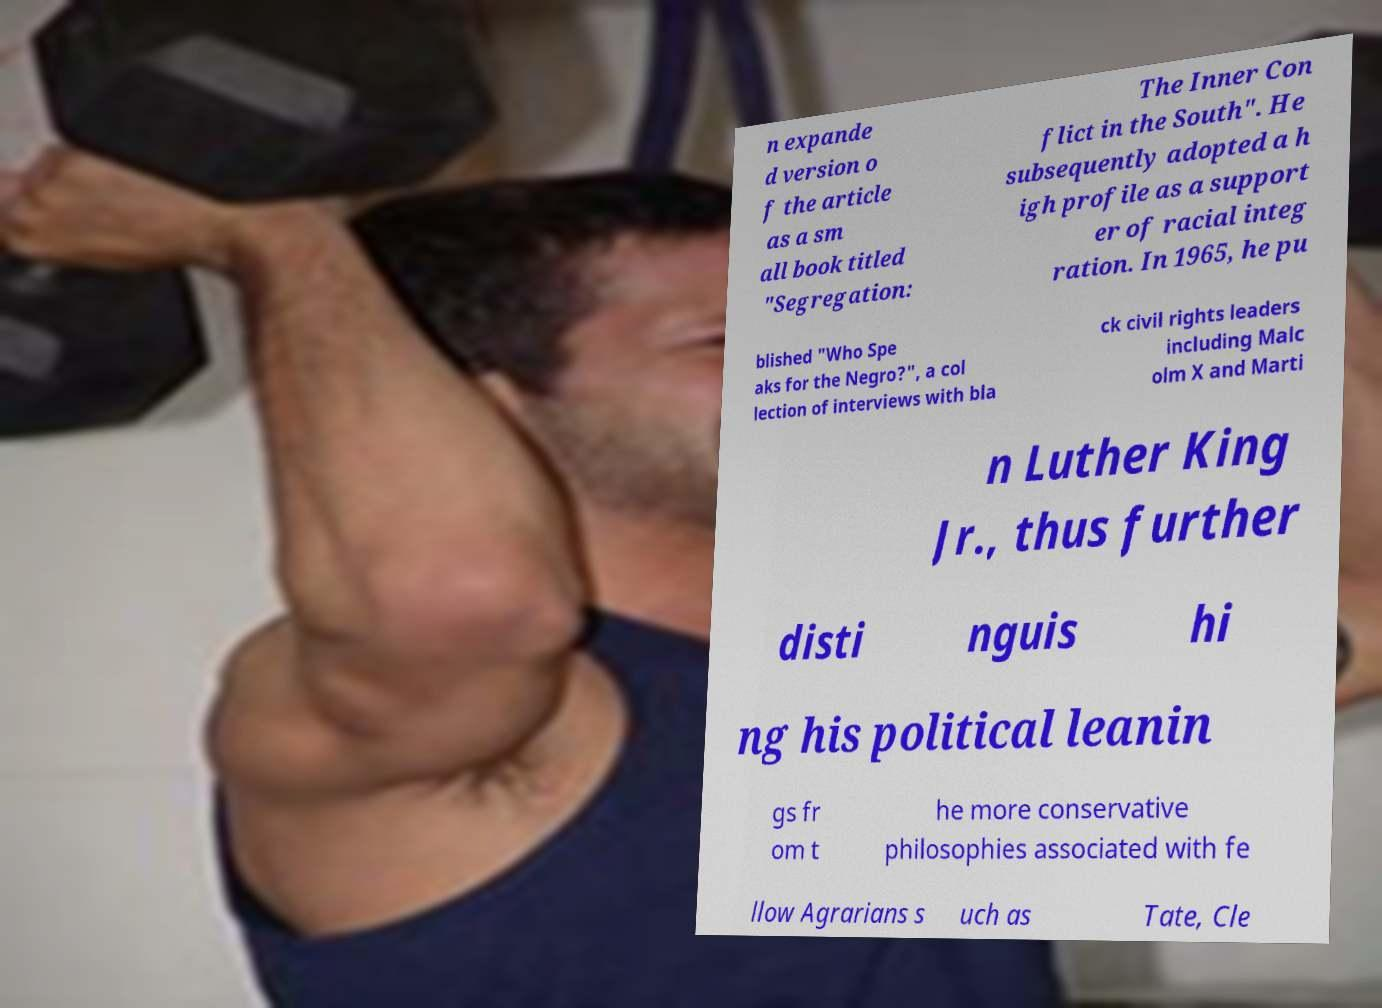There's text embedded in this image that I need extracted. Can you transcribe it verbatim? n expande d version o f the article as a sm all book titled "Segregation: The Inner Con flict in the South". He subsequently adopted a h igh profile as a support er of racial integ ration. In 1965, he pu blished "Who Spe aks for the Negro?", a col lection of interviews with bla ck civil rights leaders including Malc olm X and Marti n Luther King Jr., thus further disti nguis hi ng his political leanin gs fr om t he more conservative philosophies associated with fe llow Agrarians s uch as Tate, Cle 